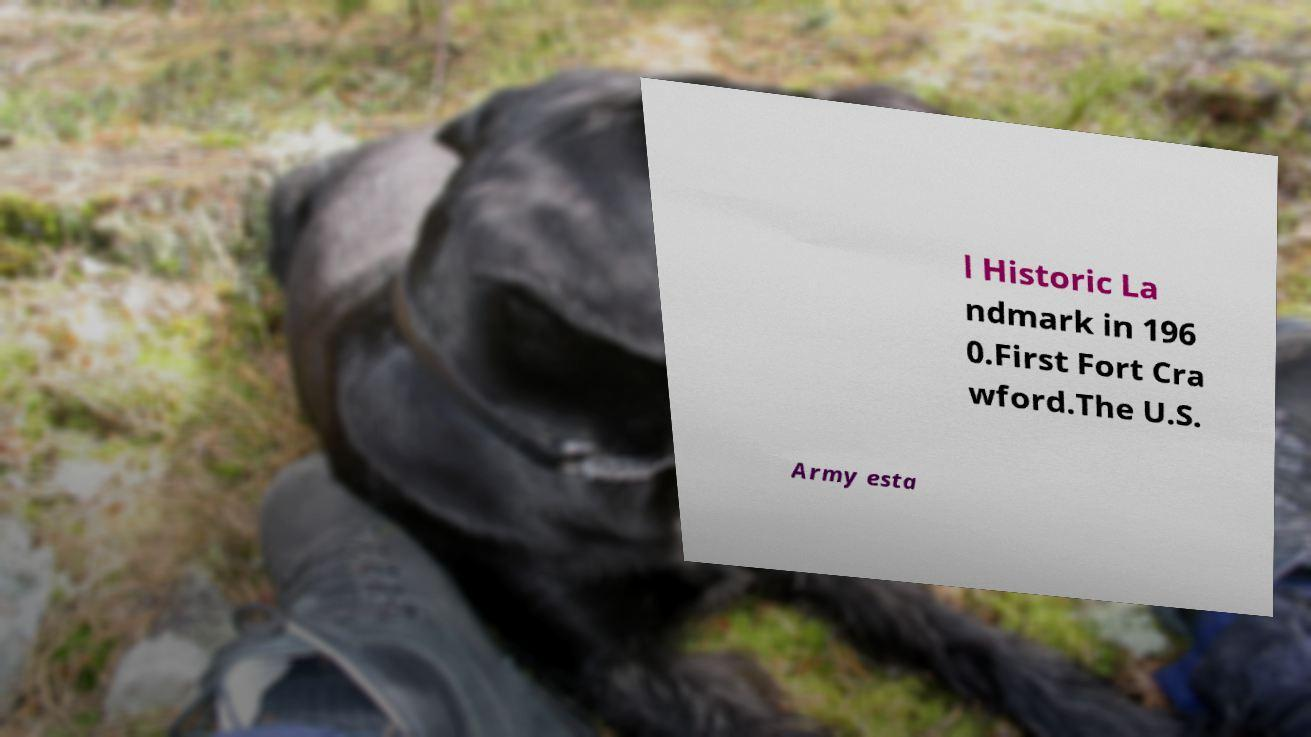Can you read and provide the text displayed in the image?This photo seems to have some interesting text. Can you extract and type it out for me? l Historic La ndmark in 196 0.First Fort Cra wford.The U.S. Army esta 